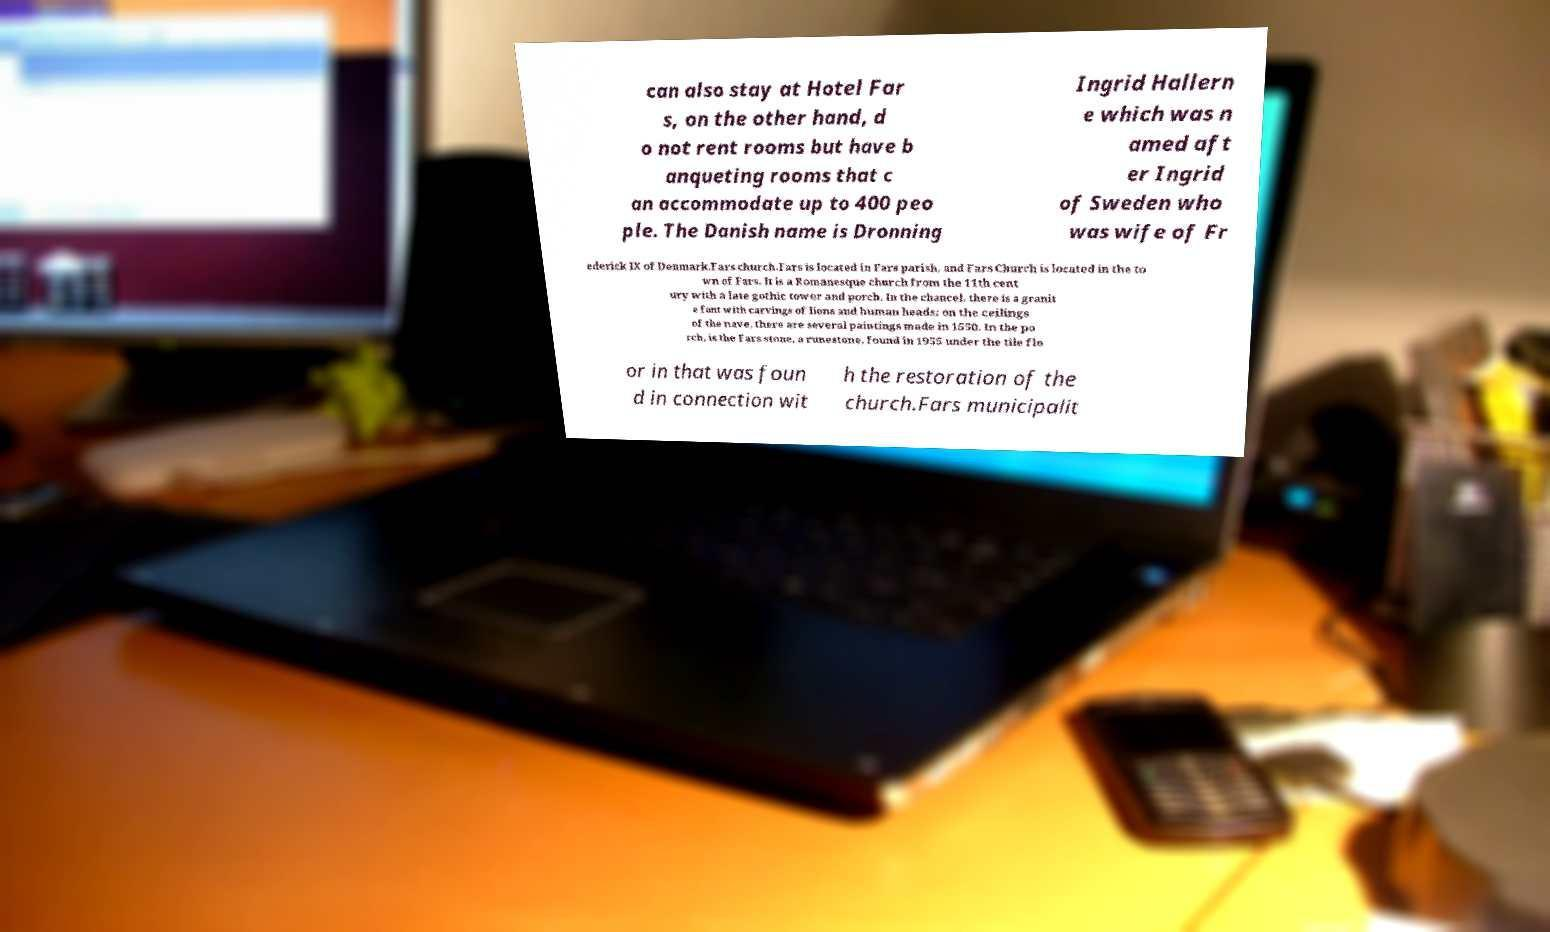Please read and relay the text visible in this image. What does it say? can also stay at Hotel Far s, on the other hand, d o not rent rooms but have b anqueting rooms that c an accommodate up to 400 peo ple. The Danish name is Dronning Ingrid Hallern e which was n amed aft er Ingrid of Sweden who was wife of Fr ederick IX of Denmark.Fars church.Fars is located in Fars parish, and Fars Church is located in the to wn of Fars. It is a Romanesque church from the 11th cent ury with a late gothic tower and porch. In the chancel, there is a granit e font with carvings of lions and human heads; on the ceilings of the nave, there are several paintings made in 1550. In the po rch, is the Fars stone, a runestone, found in 1955 under the tile flo or in that was foun d in connection wit h the restoration of the church.Fars municipalit 